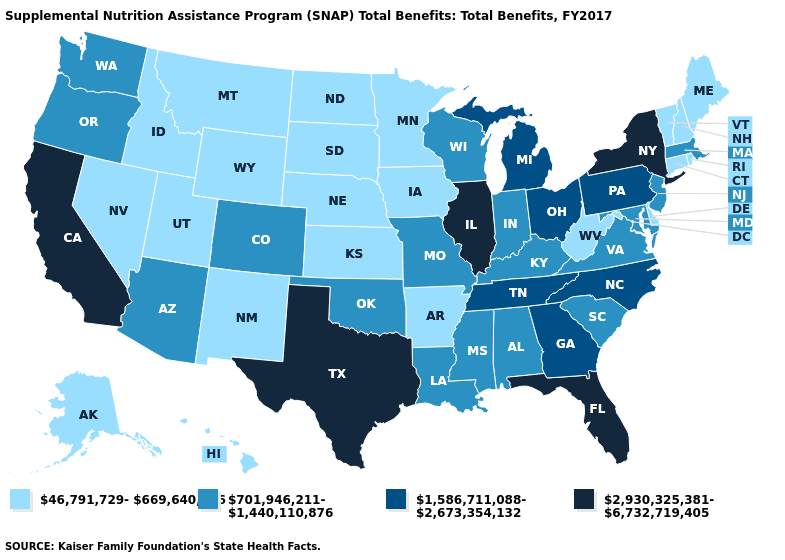What is the value of Ohio?
Answer briefly. 1,586,711,088-2,673,354,132. Name the states that have a value in the range 46,791,729-669,640,046?
Write a very short answer. Alaska, Arkansas, Connecticut, Delaware, Hawaii, Idaho, Iowa, Kansas, Maine, Minnesota, Montana, Nebraska, Nevada, New Hampshire, New Mexico, North Dakota, Rhode Island, South Dakota, Utah, Vermont, West Virginia, Wyoming. Does the first symbol in the legend represent the smallest category?
Concise answer only. Yes. What is the value of Connecticut?
Answer briefly. 46,791,729-669,640,046. Does Nebraska have a lower value than Idaho?
Write a very short answer. No. Which states have the highest value in the USA?
Give a very brief answer. California, Florida, Illinois, New York, Texas. Which states have the lowest value in the West?
Quick response, please. Alaska, Hawaii, Idaho, Montana, Nevada, New Mexico, Utah, Wyoming. What is the value of Massachusetts?
Short answer required. 701,946,211-1,440,110,876. What is the lowest value in the USA?
Be succinct. 46,791,729-669,640,046. Does New Hampshire have the lowest value in the Northeast?
Write a very short answer. Yes. Does Arizona have the highest value in the USA?
Keep it brief. No. What is the lowest value in states that border Nebraska?
Concise answer only. 46,791,729-669,640,046. What is the value of Washington?
Write a very short answer. 701,946,211-1,440,110,876. Does Utah have the lowest value in the USA?
Be succinct. Yes. Which states have the highest value in the USA?
Concise answer only. California, Florida, Illinois, New York, Texas. 